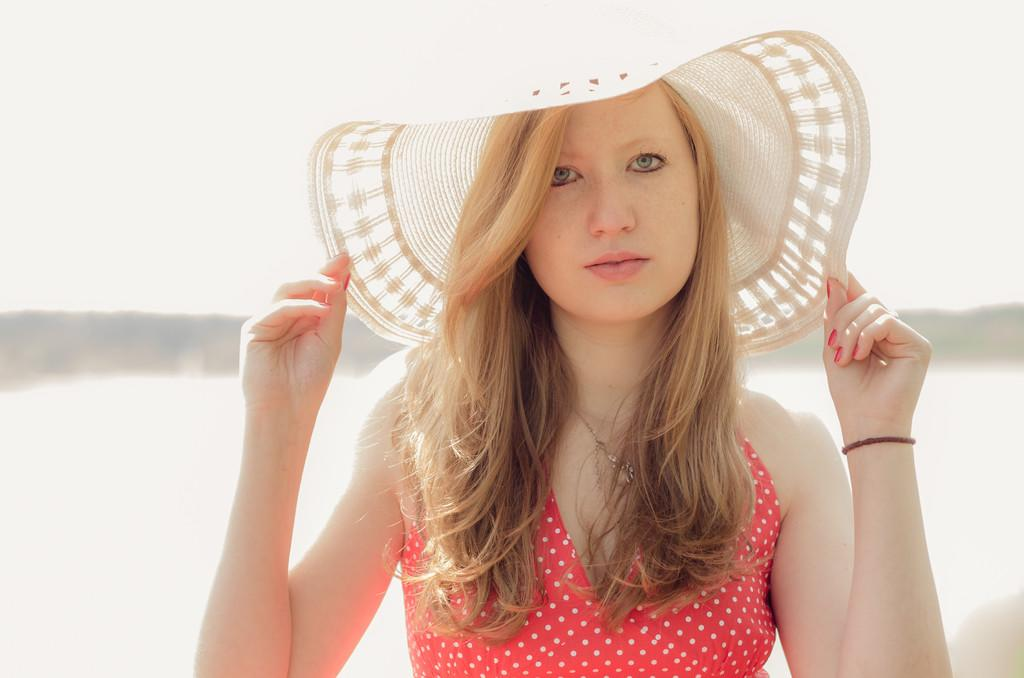Who is present in the image? There is a woman in the image. What is the woman doing in the image? The woman is standing in the image. What accessory is the woman wearing in the image? The woman is wearing a hat in the image. What is the color of the background in the image? The background of the image is white. What type of wood is the woman standing on in the image? There is no wood visible in the image; the woman is standing on a white background. 